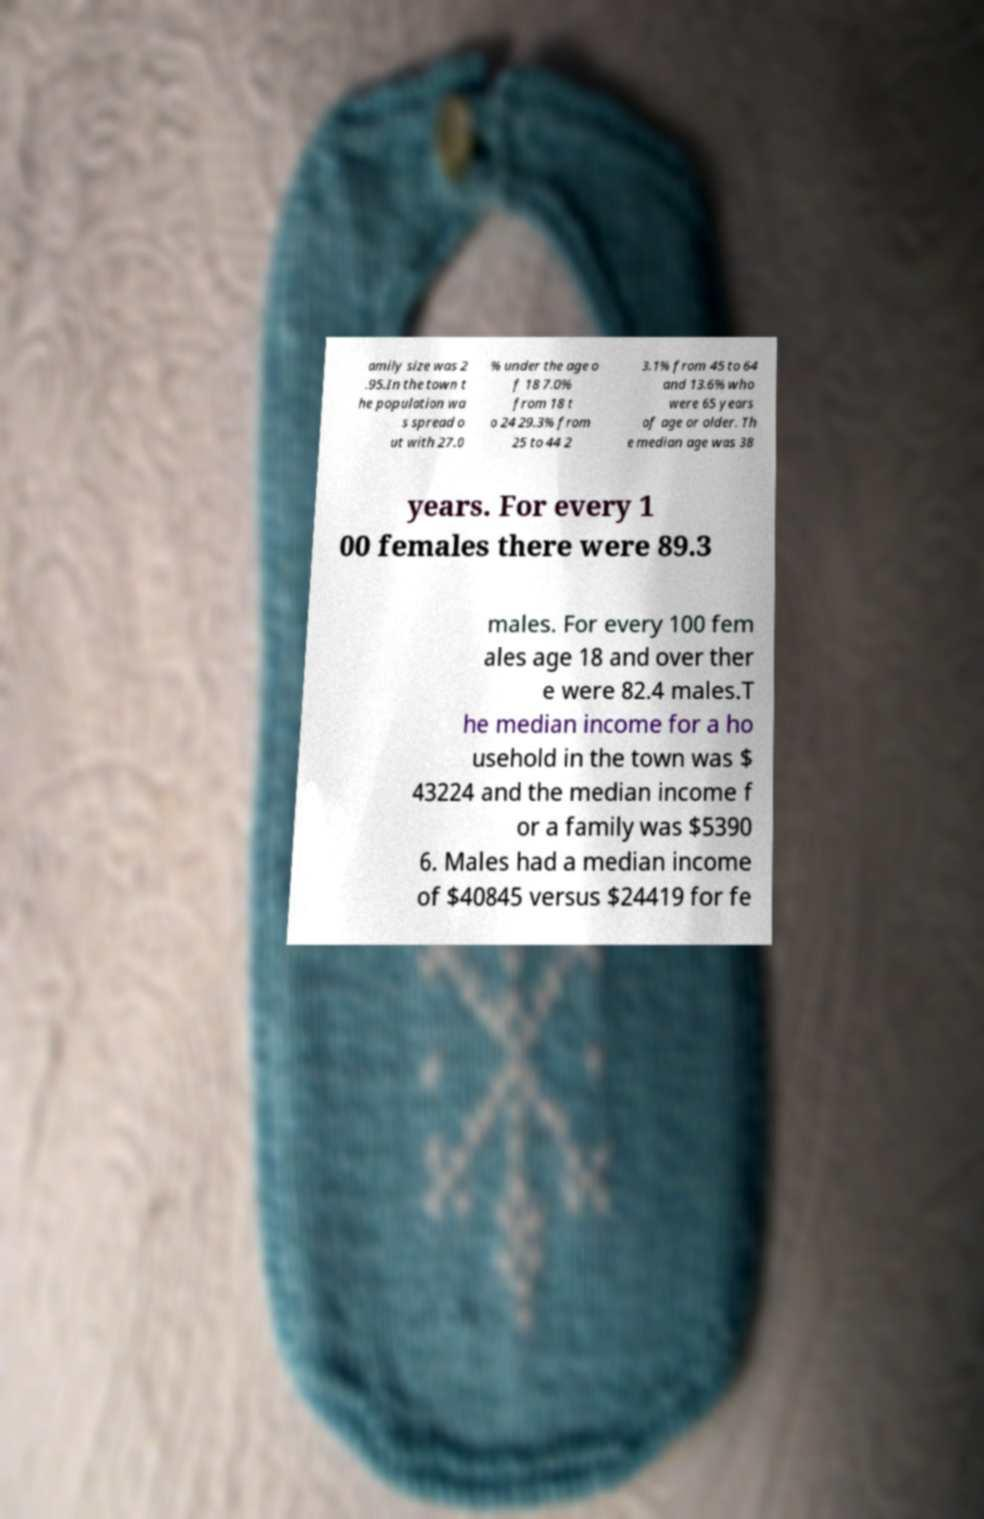Can you accurately transcribe the text from the provided image for me? amily size was 2 .95.In the town t he population wa s spread o ut with 27.0 % under the age o f 18 7.0% from 18 t o 24 29.3% from 25 to 44 2 3.1% from 45 to 64 and 13.6% who were 65 years of age or older. Th e median age was 38 years. For every 1 00 females there were 89.3 males. For every 100 fem ales age 18 and over ther e were 82.4 males.T he median income for a ho usehold in the town was $ 43224 and the median income f or a family was $5390 6. Males had a median income of $40845 versus $24419 for fe 